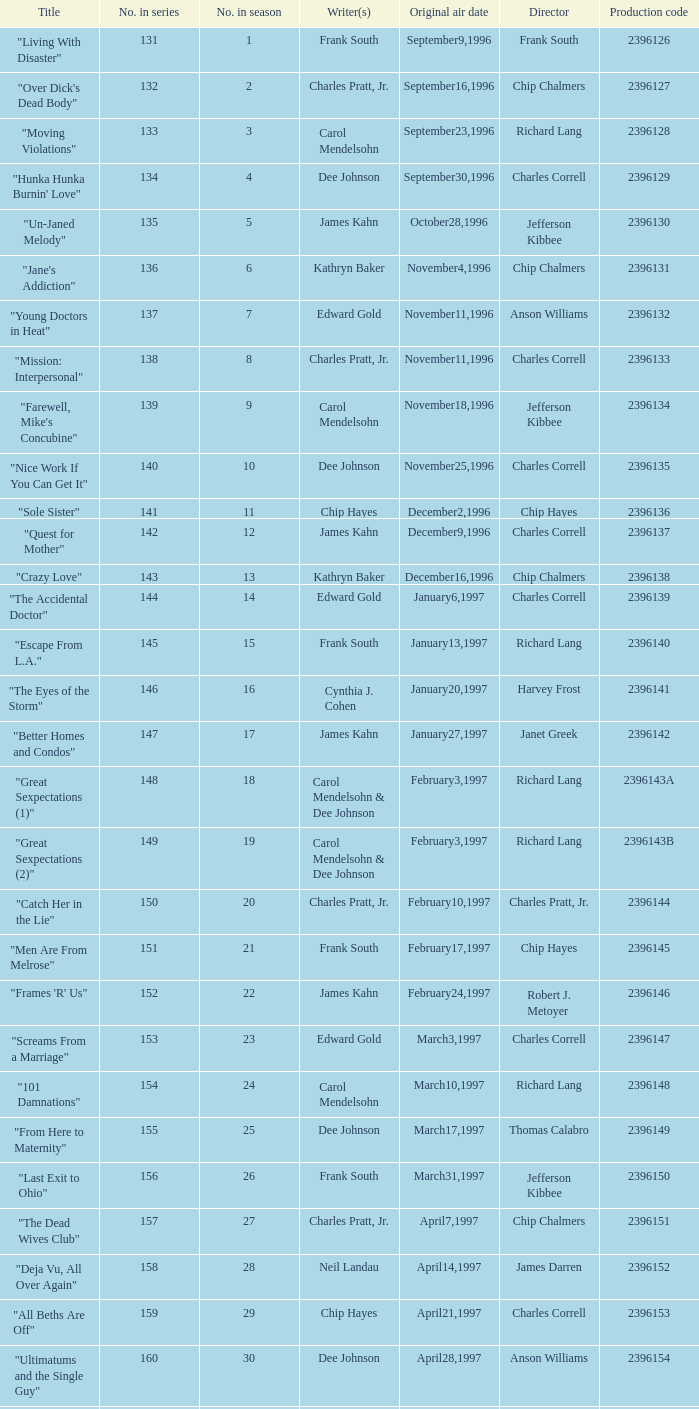Who directed the episode "Great Sexpectations (2)"? Richard Lang. 